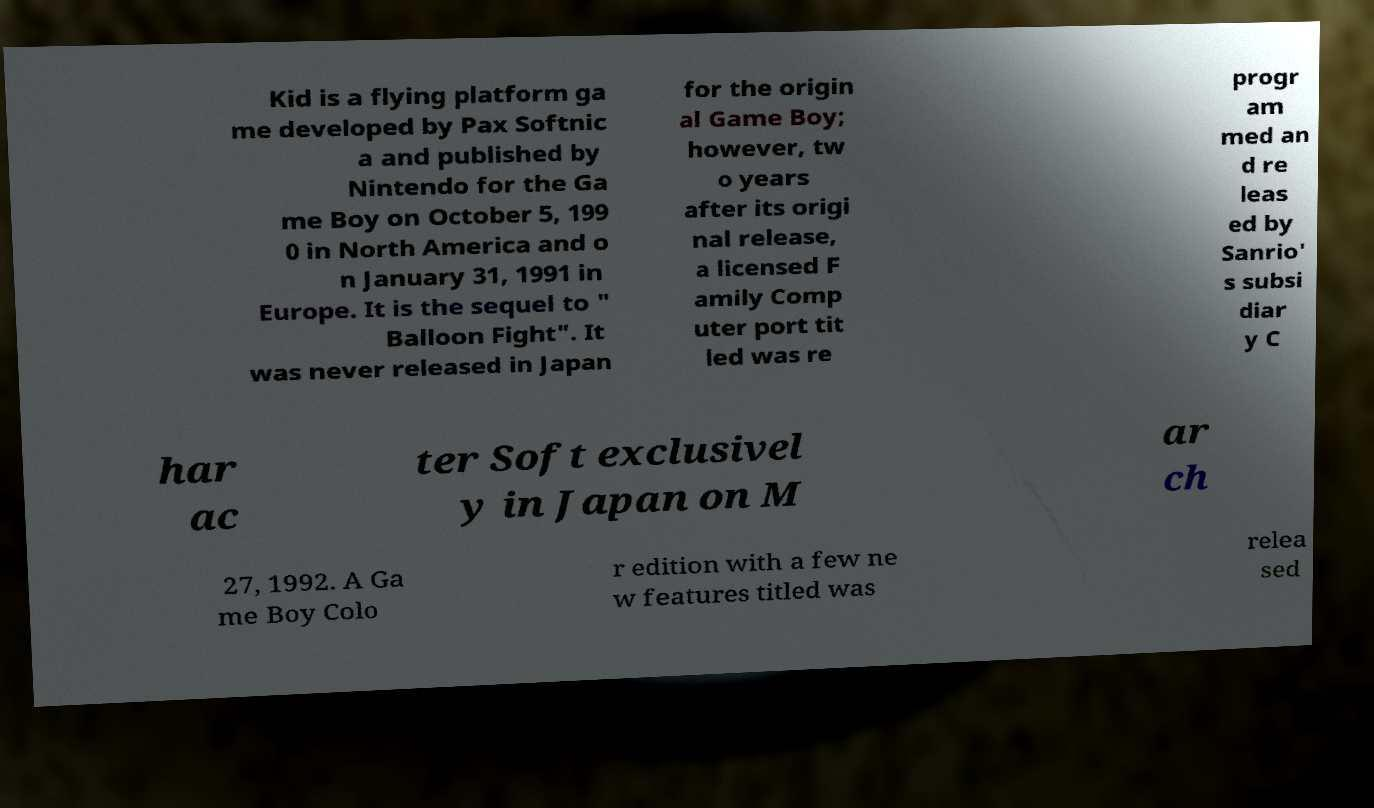There's text embedded in this image that I need extracted. Can you transcribe it verbatim? Kid is a flying platform ga me developed by Pax Softnic a and published by Nintendo for the Ga me Boy on October 5, 199 0 in North America and o n January 31, 1991 in Europe. It is the sequel to " Balloon Fight". It was never released in Japan for the origin al Game Boy; however, tw o years after its origi nal release, a licensed F amily Comp uter port tit led was re progr am med an d re leas ed by Sanrio' s subsi diar y C har ac ter Soft exclusivel y in Japan on M ar ch 27, 1992. A Ga me Boy Colo r edition with a few ne w features titled was relea sed 